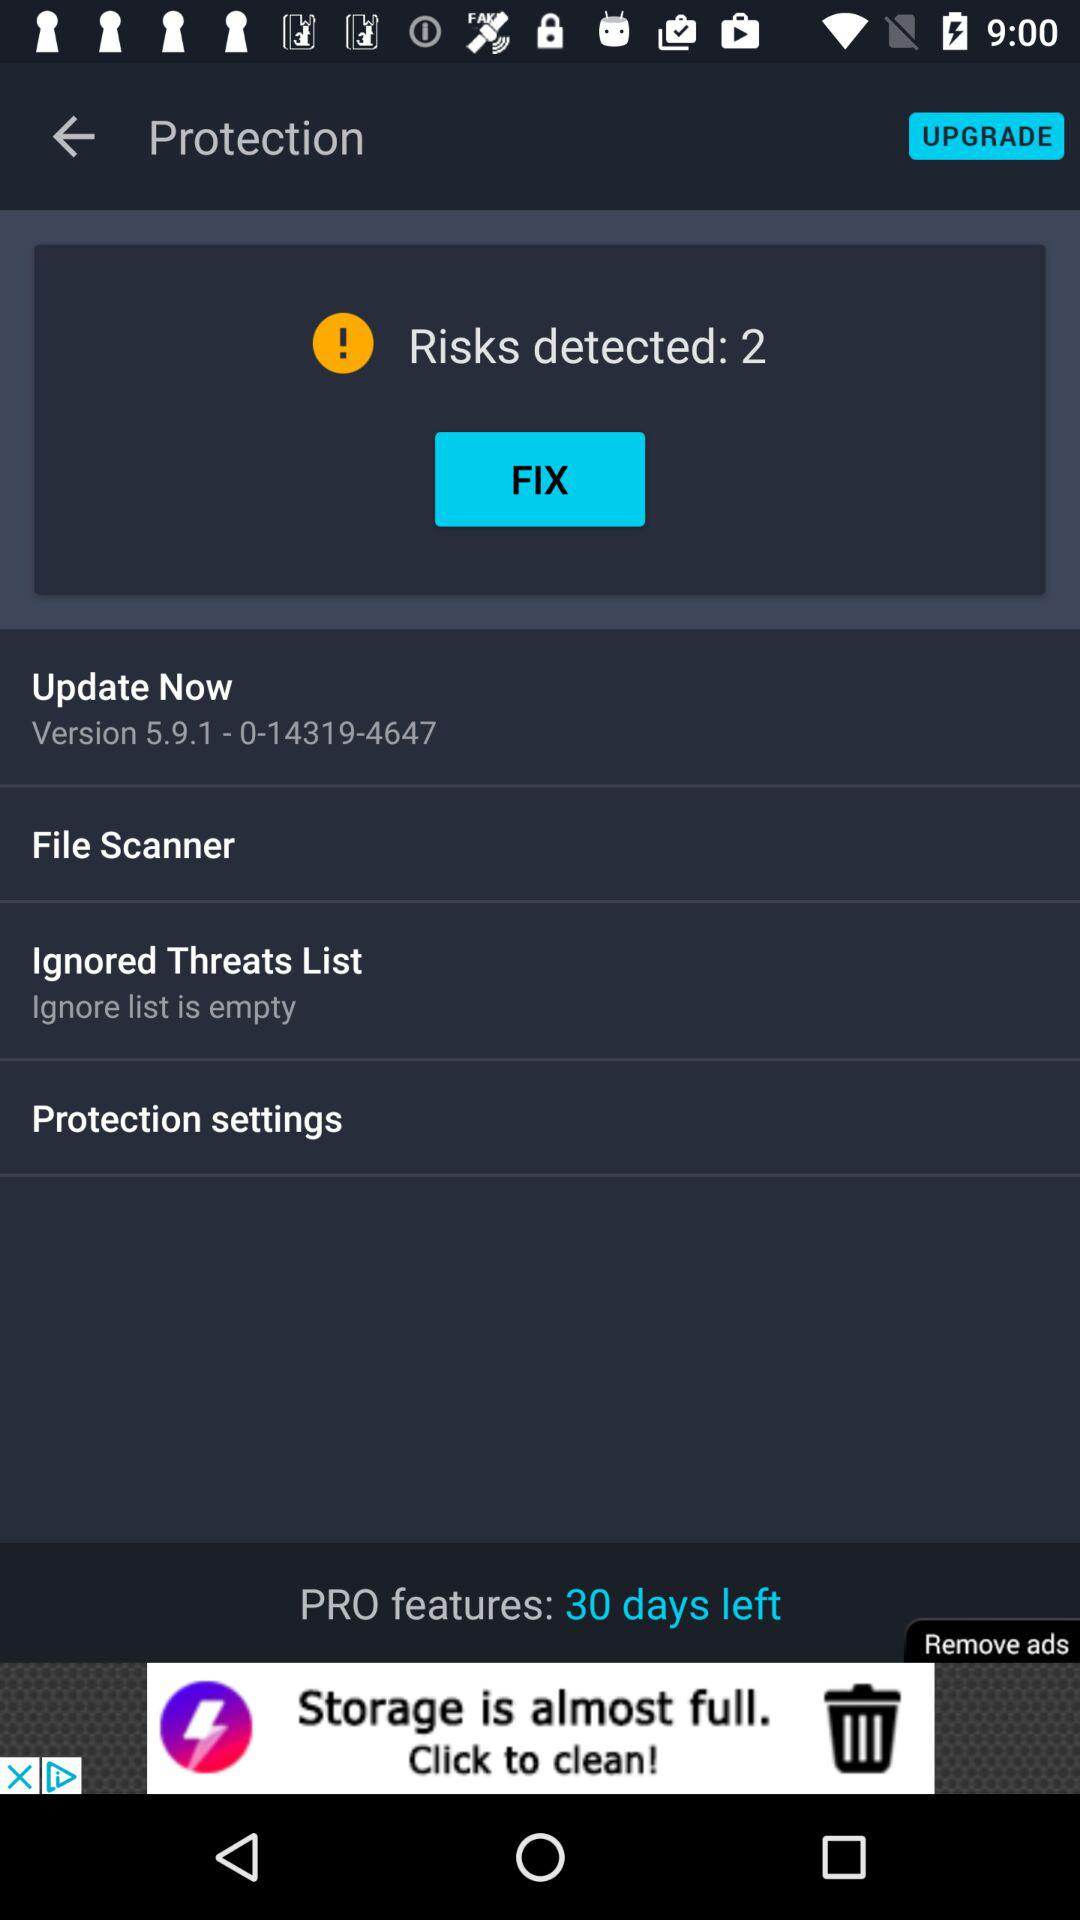What is the version? The version is 5.9.1-0-14319-4647. 